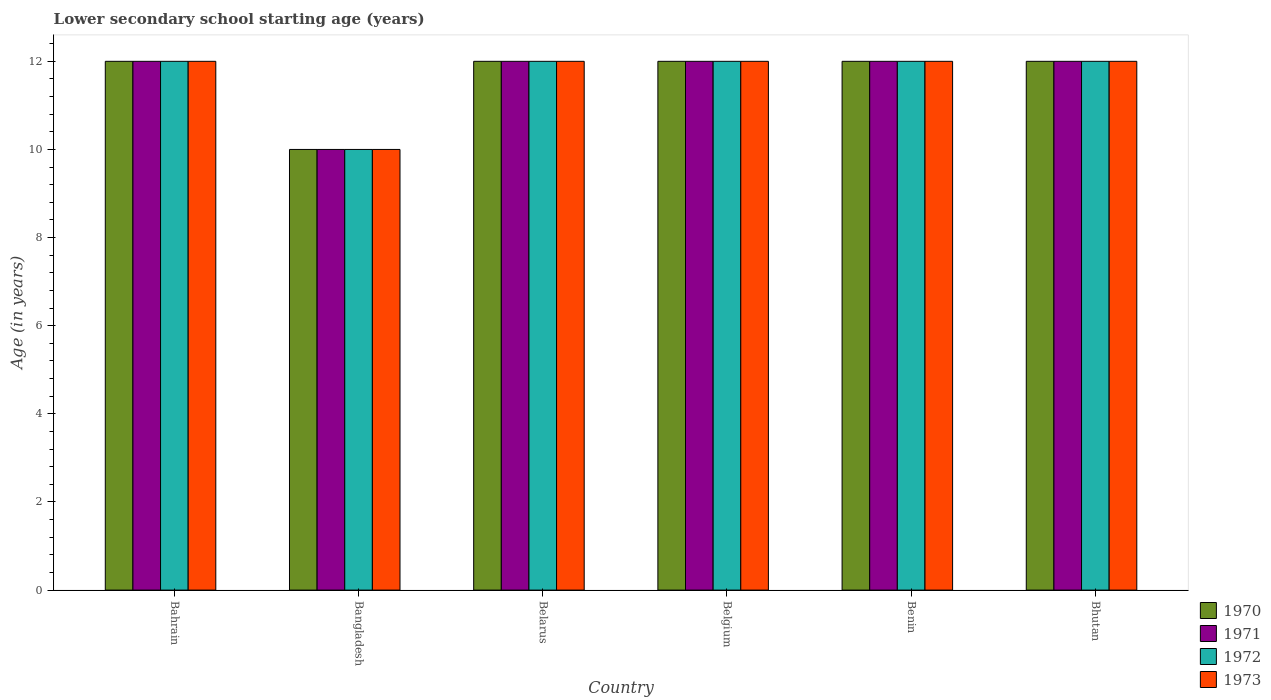How many different coloured bars are there?
Give a very brief answer. 4. Are the number of bars on each tick of the X-axis equal?
Keep it short and to the point. Yes. How many bars are there on the 5th tick from the left?
Provide a succinct answer. 4. How many bars are there on the 2nd tick from the right?
Keep it short and to the point. 4. What is the label of the 2nd group of bars from the left?
Your response must be concise. Bangladesh. What is the lower secondary school starting age of children in 1970 in Belgium?
Your answer should be very brief. 12. Across all countries, what is the maximum lower secondary school starting age of children in 1971?
Keep it short and to the point. 12. Across all countries, what is the minimum lower secondary school starting age of children in 1973?
Ensure brevity in your answer.  10. In which country was the lower secondary school starting age of children in 1970 maximum?
Make the answer very short. Bahrain. What is the difference between the lower secondary school starting age of children in 1971 in Belarus and the lower secondary school starting age of children in 1970 in Bangladesh?
Make the answer very short. 2. What is the average lower secondary school starting age of children in 1973 per country?
Your response must be concise. 11.67. What is the difference between the lower secondary school starting age of children of/in 1970 and lower secondary school starting age of children of/in 1972 in Belarus?
Your response must be concise. 0. In how many countries, is the lower secondary school starting age of children in 1971 greater than 8.4 years?
Keep it short and to the point. 6. Is the lower secondary school starting age of children in 1970 in Benin less than that in Bhutan?
Your answer should be compact. No. Is the difference between the lower secondary school starting age of children in 1970 in Bangladesh and Bhutan greater than the difference between the lower secondary school starting age of children in 1972 in Bangladesh and Bhutan?
Offer a terse response. No. In how many countries, is the lower secondary school starting age of children in 1971 greater than the average lower secondary school starting age of children in 1971 taken over all countries?
Ensure brevity in your answer.  5. How many countries are there in the graph?
Give a very brief answer. 6. What is the difference between two consecutive major ticks on the Y-axis?
Provide a succinct answer. 2. Does the graph contain any zero values?
Ensure brevity in your answer.  No. Does the graph contain grids?
Your answer should be compact. No. Where does the legend appear in the graph?
Keep it short and to the point. Bottom right. How are the legend labels stacked?
Provide a succinct answer. Vertical. What is the title of the graph?
Offer a very short reply. Lower secondary school starting age (years). What is the label or title of the Y-axis?
Offer a very short reply. Age (in years). What is the Age (in years) in 1970 in Bahrain?
Provide a short and direct response. 12. What is the Age (in years) of 1971 in Bahrain?
Your response must be concise. 12. What is the Age (in years) in 1971 in Bangladesh?
Provide a succinct answer. 10. What is the Age (in years) in 1972 in Bangladesh?
Give a very brief answer. 10. What is the Age (in years) of 1971 in Belarus?
Your response must be concise. 12. What is the Age (in years) in 1972 in Belarus?
Keep it short and to the point. 12. What is the Age (in years) of 1973 in Belarus?
Give a very brief answer. 12. What is the Age (in years) of 1970 in Belgium?
Make the answer very short. 12. What is the Age (in years) in 1971 in Belgium?
Make the answer very short. 12. What is the Age (in years) of 1972 in Benin?
Give a very brief answer. 12. What is the Age (in years) in 1971 in Bhutan?
Your answer should be compact. 12. What is the Age (in years) of 1973 in Bhutan?
Keep it short and to the point. 12. Across all countries, what is the maximum Age (in years) of 1972?
Give a very brief answer. 12. Across all countries, what is the minimum Age (in years) of 1970?
Offer a terse response. 10. Across all countries, what is the minimum Age (in years) of 1972?
Ensure brevity in your answer.  10. What is the total Age (in years) in 1971 in the graph?
Give a very brief answer. 70. What is the total Age (in years) of 1972 in the graph?
Your answer should be very brief. 70. What is the difference between the Age (in years) in 1970 in Bahrain and that in Bangladesh?
Offer a terse response. 2. What is the difference between the Age (in years) of 1971 in Bahrain and that in Bangladesh?
Offer a very short reply. 2. What is the difference between the Age (in years) in 1973 in Bahrain and that in Bangladesh?
Offer a very short reply. 2. What is the difference between the Age (in years) of 1970 in Bahrain and that in Belarus?
Your response must be concise. 0. What is the difference between the Age (in years) of 1972 in Bahrain and that in Belarus?
Give a very brief answer. 0. What is the difference between the Age (in years) in 1973 in Bahrain and that in Belarus?
Offer a very short reply. 0. What is the difference between the Age (in years) of 1971 in Bahrain and that in Belgium?
Offer a very short reply. 0. What is the difference between the Age (in years) in 1972 in Bahrain and that in Belgium?
Make the answer very short. 0. What is the difference between the Age (in years) of 1973 in Bahrain and that in Belgium?
Your answer should be very brief. 0. What is the difference between the Age (in years) in 1970 in Bahrain and that in Benin?
Provide a succinct answer. 0. What is the difference between the Age (in years) of 1971 in Bahrain and that in Benin?
Keep it short and to the point. 0. What is the difference between the Age (in years) of 1972 in Bahrain and that in Benin?
Ensure brevity in your answer.  0. What is the difference between the Age (in years) in 1973 in Bahrain and that in Benin?
Offer a terse response. 0. What is the difference between the Age (in years) of 1970 in Bahrain and that in Bhutan?
Your answer should be compact. 0. What is the difference between the Age (in years) in 1971 in Bahrain and that in Bhutan?
Provide a short and direct response. 0. What is the difference between the Age (in years) of 1972 in Bahrain and that in Bhutan?
Offer a very short reply. 0. What is the difference between the Age (in years) of 1971 in Bangladesh and that in Belarus?
Your answer should be compact. -2. What is the difference between the Age (in years) of 1972 in Bangladesh and that in Belarus?
Your answer should be very brief. -2. What is the difference between the Age (in years) in 1973 in Bangladesh and that in Belarus?
Give a very brief answer. -2. What is the difference between the Age (in years) of 1970 in Bangladesh and that in Belgium?
Make the answer very short. -2. What is the difference between the Age (in years) in 1971 in Bangladesh and that in Belgium?
Keep it short and to the point. -2. What is the difference between the Age (in years) of 1973 in Bangladesh and that in Belgium?
Ensure brevity in your answer.  -2. What is the difference between the Age (in years) of 1971 in Bangladesh and that in Benin?
Give a very brief answer. -2. What is the difference between the Age (in years) in 1972 in Bangladesh and that in Benin?
Your response must be concise. -2. What is the difference between the Age (in years) of 1972 in Belarus and that in Belgium?
Your answer should be very brief. 0. What is the difference between the Age (in years) of 1970 in Belarus and that in Benin?
Give a very brief answer. 0. What is the difference between the Age (in years) of 1972 in Belarus and that in Benin?
Provide a succinct answer. 0. What is the difference between the Age (in years) of 1972 in Belarus and that in Bhutan?
Your answer should be compact. 0. What is the difference between the Age (in years) in 1973 in Belgium and that in Benin?
Make the answer very short. 0. What is the difference between the Age (in years) in 1973 in Belgium and that in Bhutan?
Make the answer very short. 0. What is the difference between the Age (in years) of 1973 in Benin and that in Bhutan?
Your answer should be compact. 0. What is the difference between the Age (in years) of 1970 in Bahrain and the Age (in years) of 1972 in Bangladesh?
Your answer should be very brief. 2. What is the difference between the Age (in years) in 1971 in Bahrain and the Age (in years) in 1972 in Bangladesh?
Keep it short and to the point. 2. What is the difference between the Age (in years) in 1970 in Bahrain and the Age (in years) in 1971 in Belarus?
Your response must be concise. 0. What is the difference between the Age (in years) in 1971 in Bahrain and the Age (in years) in 1973 in Belarus?
Offer a very short reply. 0. What is the difference between the Age (in years) of 1971 in Bahrain and the Age (in years) of 1972 in Belgium?
Your response must be concise. 0. What is the difference between the Age (in years) of 1972 in Bahrain and the Age (in years) of 1973 in Belgium?
Offer a terse response. 0. What is the difference between the Age (in years) of 1970 in Bahrain and the Age (in years) of 1971 in Benin?
Offer a very short reply. 0. What is the difference between the Age (in years) of 1971 in Bahrain and the Age (in years) of 1973 in Benin?
Your answer should be compact. 0. What is the difference between the Age (in years) in 1972 in Bahrain and the Age (in years) in 1973 in Benin?
Provide a succinct answer. 0. What is the difference between the Age (in years) in 1970 in Bahrain and the Age (in years) in 1971 in Bhutan?
Provide a succinct answer. 0. What is the difference between the Age (in years) of 1970 in Bahrain and the Age (in years) of 1972 in Bhutan?
Provide a short and direct response. 0. What is the difference between the Age (in years) of 1970 in Bahrain and the Age (in years) of 1973 in Bhutan?
Ensure brevity in your answer.  0. What is the difference between the Age (in years) of 1971 in Bahrain and the Age (in years) of 1972 in Bhutan?
Your answer should be compact. 0. What is the difference between the Age (in years) in 1972 in Bahrain and the Age (in years) in 1973 in Bhutan?
Provide a succinct answer. 0. What is the difference between the Age (in years) in 1970 in Bangladesh and the Age (in years) in 1971 in Belarus?
Provide a short and direct response. -2. What is the difference between the Age (in years) of 1971 in Bangladesh and the Age (in years) of 1972 in Belarus?
Ensure brevity in your answer.  -2. What is the difference between the Age (in years) of 1972 in Bangladesh and the Age (in years) of 1973 in Belarus?
Your response must be concise. -2. What is the difference between the Age (in years) in 1970 in Bangladesh and the Age (in years) in 1971 in Belgium?
Keep it short and to the point. -2. What is the difference between the Age (in years) of 1970 in Bangladesh and the Age (in years) of 1972 in Belgium?
Keep it short and to the point. -2. What is the difference between the Age (in years) in 1970 in Bangladesh and the Age (in years) in 1973 in Belgium?
Provide a succinct answer. -2. What is the difference between the Age (in years) in 1971 in Bangladesh and the Age (in years) in 1973 in Belgium?
Make the answer very short. -2. What is the difference between the Age (in years) in 1972 in Bangladesh and the Age (in years) in 1973 in Belgium?
Your response must be concise. -2. What is the difference between the Age (in years) of 1970 in Bangladesh and the Age (in years) of 1971 in Benin?
Offer a very short reply. -2. What is the difference between the Age (in years) in 1970 in Bangladesh and the Age (in years) in 1973 in Benin?
Offer a very short reply. -2. What is the difference between the Age (in years) in 1971 in Bangladesh and the Age (in years) in 1972 in Benin?
Keep it short and to the point. -2. What is the difference between the Age (in years) of 1971 in Bangladesh and the Age (in years) of 1973 in Benin?
Provide a short and direct response. -2. What is the difference between the Age (in years) of 1970 in Bangladesh and the Age (in years) of 1971 in Bhutan?
Your answer should be compact. -2. What is the difference between the Age (in years) of 1970 in Bangladesh and the Age (in years) of 1972 in Bhutan?
Offer a terse response. -2. What is the difference between the Age (in years) in 1970 in Bangladesh and the Age (in years) in 1973 in Bhutan?
Your response must be concise. -2. What is the difference between the Age (in years) in 1971 in Bangladesh and the Age (in years) in 1972 in Bhutan?
Offer a very short reply. -2. What is the difference between the Age (in years) of 1971 in Bangladesh and the Age (in years) of 1973 in Bhutan?
Keep it short and to the point. -2. What is the difference between the Age (in years) in 1970 in Belarus and the Age (in years) in 1971 in Belgium?
Your response must be concise. 0. What is the difference between the Age (in years) in 1970 in Belarus and the Age (in years) in 1973 in Belgium?
Your answer should be very brief. 0. What is the difference between the Age (in years) of 1972 in Belarus and the Age (in years) of 1973 in Belgium?
Give a very brief answer. 0. What is the difference between the Age (in years) in 1970 in Belarus and the Age (in years) in 1973 in Benin?
Keep it short and to the point. 0. What is the difference between the Age (in years) in 1970 in Belarus and the Age (in years) in 1973 in Bhutan?
Give a very brief answer. 0. What is the difference between the Age (in years) of 1972 in Belarus and the Age (in years) of 1973 in Bhutan?
Ensure brevity in your answer.  0. What is the difference between the Age (in years) in 1971 in Belgium and the Age (in years) in 1973 in Benin?
Provide a short and direct response. 0. What is the difference between the Age (in years) of 1970 in Belgium and the Age (in years) of 1972 in Bhutan?
Ensure brevity in your answer.  0. What is the difference between the Age (in years) of 1971 in Belgium and the Age (in years) of 1973 in Bhutan?
Your answer should be very brief. 0. What is the difference between the Age (in years) in 1972 in Belgium and the Age (in years) in 1973 in Bhutan?
Provide a succinct answer. 0. What is the difference between the Age (in years) of 1970 in Benin and the Age (in years) of 1973 in Bhutan?
Make the answer very short. 0. What is the difference between the Age (in years) in 1971 in Benin and the Age (in years) in 1973 in Bhutan?
Offer a very short reply. 0. What is the difference between the Age (in years) in 1972 in Benin and the Age (in years) in 1973 in Bhutan?
Ensure brevity in your answer.  0. What is the average Age (in years) in 1970 per country?
Provide a short and direct response. 11.67. What is the average Age (in years) of 1971 per country?
Your response must be concise. 11.67. What is the average Age (in years) in 1972 per country?
Offer a very short reply. 11.67. What is the average Age (in years) of 1973 per country?
Your answer should be very brief. 11.67. What is the difference between the Age (in years) of 1970 and Age (in years) of 1971 in Bahrain?
Offer a very short reply. 0. What is the difference between the Age (in years) in 1970 and Age (in years) in 1972 in Bahrain?
Keep it short and to the point. 0. What is the difference between the Age (in years) of 1971 and Age (in years) of 1973 in Bahrain?
Your response must be concise. 0. What is the difference between the Age (in years) of 1970 and Age (in years) of 1971 in Bangladesh?
Give a very brief answer. 0. What is the difference between the Age (in years) of 1970 and Age (in years) of 1972 in Bangladesh?
Provide a short and direct response. 0. What is the difference between the Age (in years) in 1970 and Age (in years) in 1973 in Bangladesh?
Your response must be concise. 0. What is the difference between the Age (in years) in 1971 and Age (in years) in 1972 in Bangladesh?
Provide a short and direct response. 0. What is the difference between the Age (in years) of 1970 and Age (in years) of 1973 in Belarus?
Your answer should be compact. 0. What is the difference between the Age (in years) in 1970 and Age (in years) in 1971 in Belgium?
Your response must be concise. 0. What is the difference between the Age (in years) in 1971 and Age (in years) in 1972 in Belgium?
Offer a terse response. 0. What is the difference between the Age (in years) of 1972 and Age (in years) of 1973 in Belgium?
Your response must be concise. 0. What is the difference between the Age (in years) in 1970 and Age (in years) in 1971 in Benin?
Offer a very short reply. 0. What is the difference between the Age (in years) in 1970 and Age (in years) in 1972 in Benin?
Your response must be concise. 0. What is the difference between the Age (in years) of 1971 and Age (in years) of 1973 in Benin?
Your answer should be compact. 0. What is the difference between the Age (in years) in 1972 and Age (in years) in 1973 in Benin?
Offer a very short reply. 0. What is the difference between the Age (in years) of 1970 and Age (in years) of 1971 in Bhutan?
Provide a succinct answer. 0. What is the difference between the Age (in years) in 1971 and Age (in years) in 1972 in Bhutan?
Keep it short and to the point. 0. What is the difference between the Age (in years) in 1972 and Age (in years) in 1973 in Bhutan?
Provide a short and direct response. 0. What is the ratio of the Age (in years) of 1970 in Bahrain to that in Bangladesh?
Keep it short and to the point. 1.2. What is the ratio of the Age (in years) of 1973 in Bahrain to that in Bangladesh?
Keep it short and to the point. 1.2. What is the ratio of the Age (in years) of 1970 in Bahrain to that in Belarus?
Provide a short and direct response. 1. What is the ratio of the Age (in years) of 1971 in Bahrain to that in Belarus?
Ensure brevity in your answer.  1. What is the ratio of the Age (in years) in 1971 in Bahrain to that in Belgium?
Your answer should be very brief. 1. What is the ratio of the Age (in years) in 1972 in Bahrain to that in Belgium?
Give a very brief answer. 1. What is the ratio of the Age (in years) in 1971 in Bahrain to that in Benin?
Your answer should be very brief. 1. What is the ratio of the Age (in years) of 1971 in Bahrain to that in Bhutan?
Keep it short and to the point. 1. What is the ratio of the Age (in years) of 1972 in Bahrain to that in Bhutan?
Your response must be concise. 1. What is the ratio of the Age (in years) of 1973 in Bahrain to that in Bhutan?
Offer a very short reply. 1. What is the ratio of the Age (in years) in 1970 in Bangladesh to that in Belarus?
Your response must be concise. 0.83. What is the ratio of the Age (in years) in 1972 in Bangladesh to that in Belarus?
Provide a short and direct response. 0.83. What is the ratio of the Age (in years) of 1971 in Bangladesh to that in Belgium?
Your answer should be very brief. 0.83. What is the ratio of the Age (in years) of 1971 in Bangladesh to that in Benin?
Provide a short and direct response. 0.83. What is the ratio of the Age (in years) in 1973 in Bangladesh to that in Benin?
Your answer should be very brief. 0.83. What is the ratio of the Age (in years) in 1973 in Bangladesh to that in Bhutan?
Give a very brief answer. 0.83. What is the ratio of the Age (in years) of 1971 in Belarus to that in Belgium?
Offer a very short reply. 1. What is the ratio of the Age (in years) of 1972 in Belarus to that in Belgium?
Provide a short and direct response. 1. What is the ratio of the Age (in years) in 1973 in Belarus to that in Belgium?
Provide a short and direct response. 1. What is the ratio of the Age (in years) of 1970 in Belarus to that in Benin?
Ensure brevity in your answer.  1. What is the ratio of the Age (in years) of 1972 in Belarus to that in Benin?
Provide a succinct answer. 1. What is the ratio of the Age (in years) in 1970 in Belarus to that in Bhutan?
Keep it short and to the point. 1. What is the ratio of the Age (in years) of 1972 in Belarus to that in Bhutan?
Give a very brief answer. 1. What is the ratio of the Age (in years) of 1973 in Belarus to that in Bhutan?
Your answer should be very brief. 1. What is the ratio of the Age (in years) in 1970 in Belgium to that in Benin?
Your response must be concise. 1. What is the ratio of the Age (in years) in 1971 in Belgium to that in Benin?
Ensure brevity in your answer.  1. What is the ratio of the Age (in years) of 1971 in Belgium to that in Bhutan?
Ensure brevity in your answer.  1. What is the ratio of the Age (in years) of 1972 in Belgium to that in Bhutan?
Keep it short and to the point. 1. What is the difference between the highest and the second highest Age (in years) of 1971?
Keep it short and to the point. 0. What is the difference between the highest and the second highest Age (in years) of 1972?
Your answer should be compact. 0. What is the difference between the highest and the lowest Age (in years) in 1970?
Provide a short and direct response. 2. What is the difference between the highest and the lowest Age (in years) of 1971?
Provide a short and direct response. 2. 